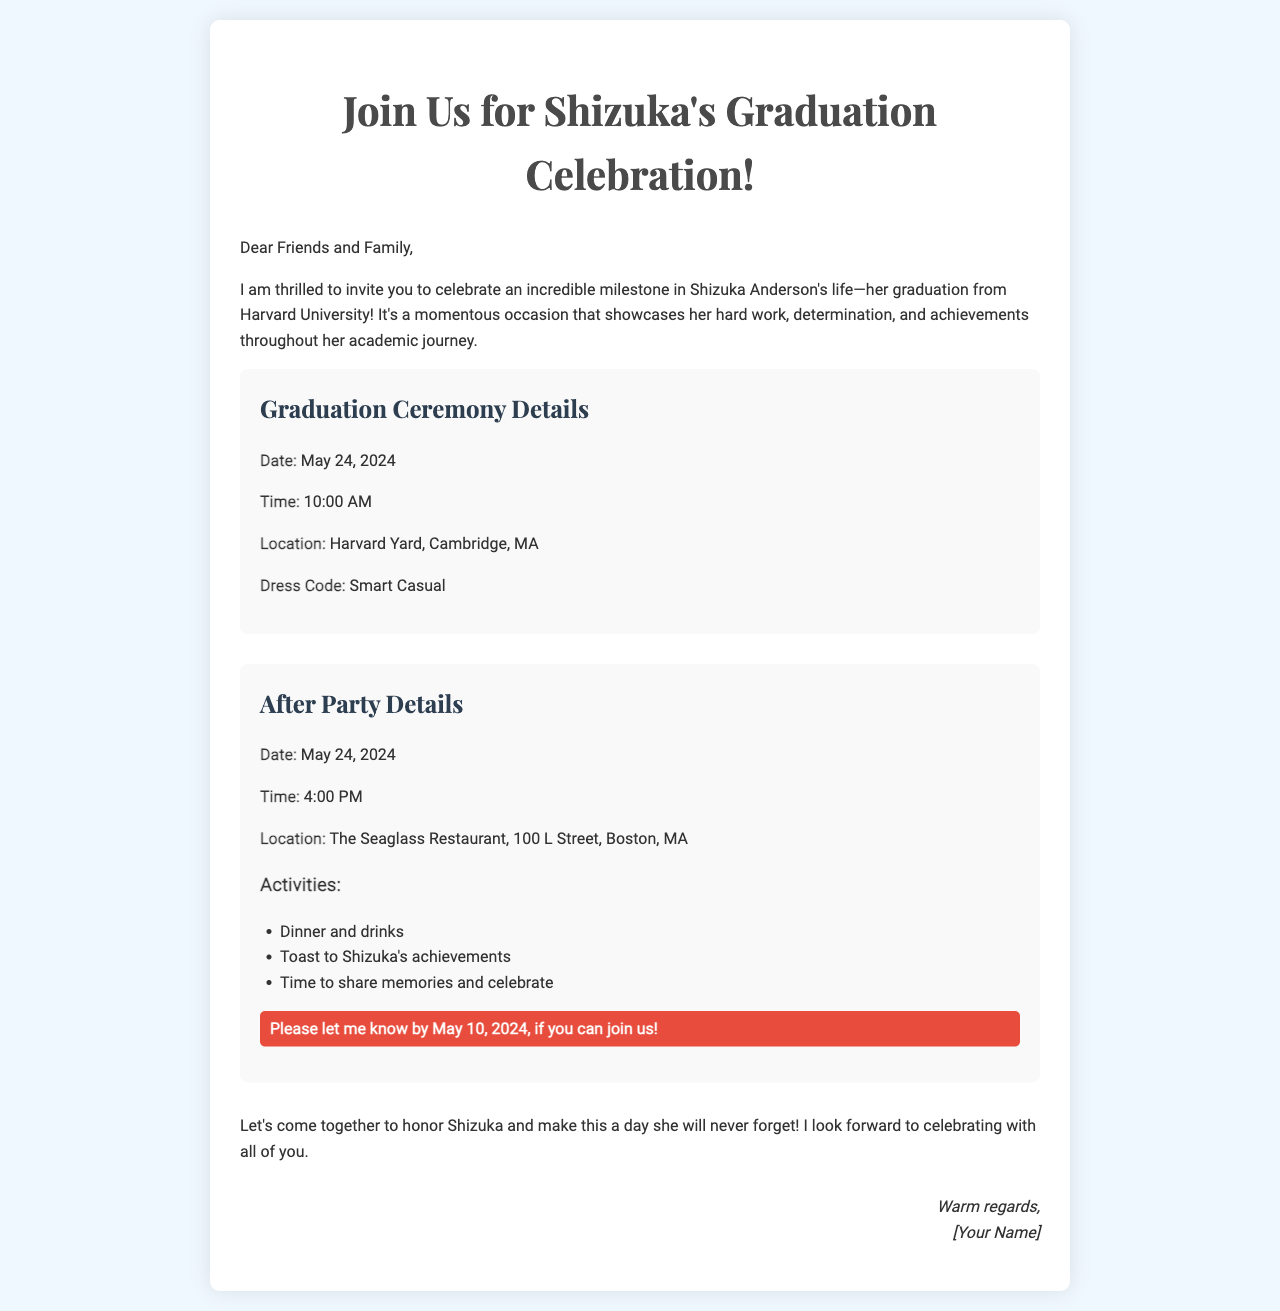what is the date of Shizuka's graduation ceremony? The date of the graduation ceremony is explicitly stated in the document.
Answer: May 24, 2024 what time does the graduation ceremony start? The starting time for the ceremony is mentioned clearly.
Answer: 10:00 AM where is the graduation ceremony taking place? The location of the ceremony is provided in the document.
Answer: Harvard Yard, Cambridge, MA what is the dress code for the graduation ceremony? The document specifies the dress code for the ceremony.
Answer: Smart Casual what activities are planned for the after party? The document lists specific activities that will occur at the after party.
Answer: Dinner and drinks, Toast to Shizuka's achievements, Time to share memories and celebrate what is the deadline to RSVP for the after party? The RSVP deadline is highlighted in the document for clarity.
Answer: May 10, 2024 how long after the graduation ceremony does the after party start? To determine the time difference, we can subtract the ceremony start time from the after party start time.
Answer: 6 hours who is signing off the invitation? The closing section of the document includes the name of the person sending the invitation.
Answer: [Your Name] 